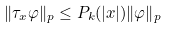Convert formula to latex. <formula><loc_0><loc_0><loc_500><loc_500>\| \tau _ { x } \varphi \| _ { p } \leq P _ { k } ( | x | ) \| \varphi \| _ { p }</formula> 